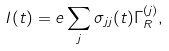<formula> <loc_0><loc_0><loc_500><loc_500>I ( t ) = e \sum _ { j } \sigma _ { j j } ( t ) \Gamma ^ { ( j ) } _ { R } ,</formula> 